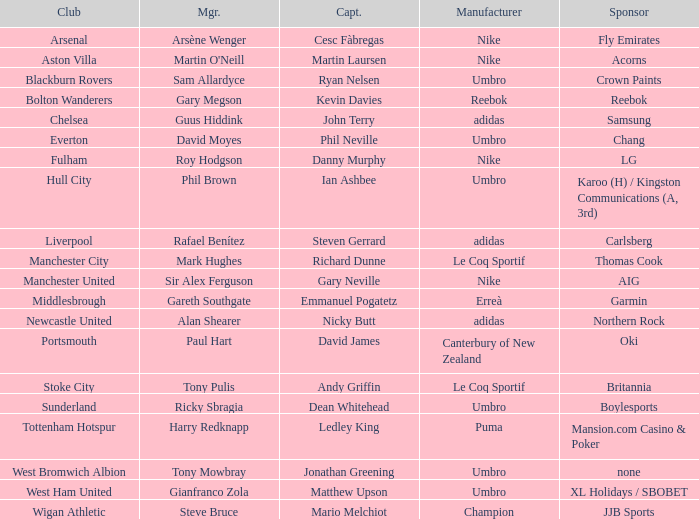In which club is Ledley King a captain? Tottenham Hotspur. 